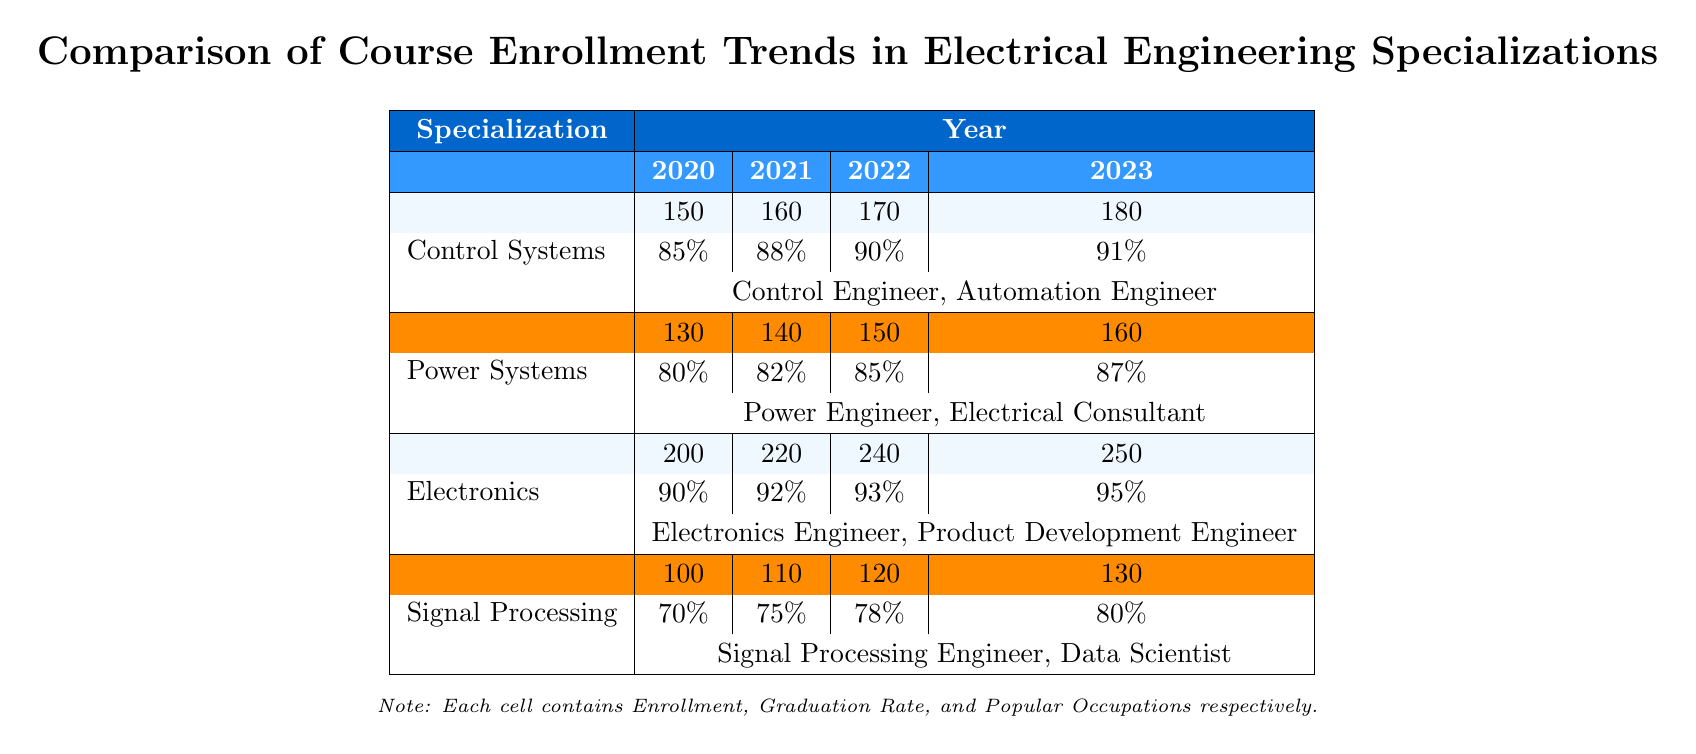What was the enrollment for Electronics in 2021? The table indicates that the enrollment for Electronics in 2021 was 220 students.
Answer: 220 What is the graduation rate for Control Systems in 2023? According to the table, the graduation rate for Control Systems in 2023 is 91%.
Answer: 91% Which specialization had the highest enrollment in 2022? By comparing the enrollment values for 2022, Electronics had the highest enrollment with 240 students.
Answer: Electronics What is the average graduation rate for Signal Processing over the years 2020 to 2023? The graduation rates for Signal Processing are 70%, 75%, 78%, and 80%. The average is (70 + 75 + 78 + 80) / 4 = 75.75%.
Answer: 75.75% Did the enrollment for Power Systems increase from 2020 to 2023? Yes, the enrollment for Power Systems increased from 130 students in 2020 to 160 students in 2023, which indicates a positive trend.
Answer: Yes What is the total enrollment for Control Systems from 2020 to 2023? The total enrollment can be calculated by adding the enrollment numbers: 150 (2020) + 160 (2021) + 170 (2022) + 180 (2023) = 660.
Answer: 660 Which specialization had the lowest graduation rate in 2020? Looking at the graduation rates for 2020, Signal Processing had the lowest graduation rate at 70%.
Answer: Signal Processing Is the popular occupation for Electronics consistent over the years? Yes, the popular occupations listed for Electronics—Electronics Engineer and Product Development Engineer—remain consistent across all four years in the table.
Answer: Yes What was the percentage increase in enrollment for Signal Processing from 2020 to 2023? The enrollment for Signal Processing increased from 100 in 2020 to 130 in 2023. The increase is (130 - 100) / 100 * 100% = 30%.
Answer: 30% How many total popular occupations are listed for Control Systems specialization? The table notes that there are two popular occupations for Control Systems—Control Engineer and Automation Engineer.
Answer: 2 